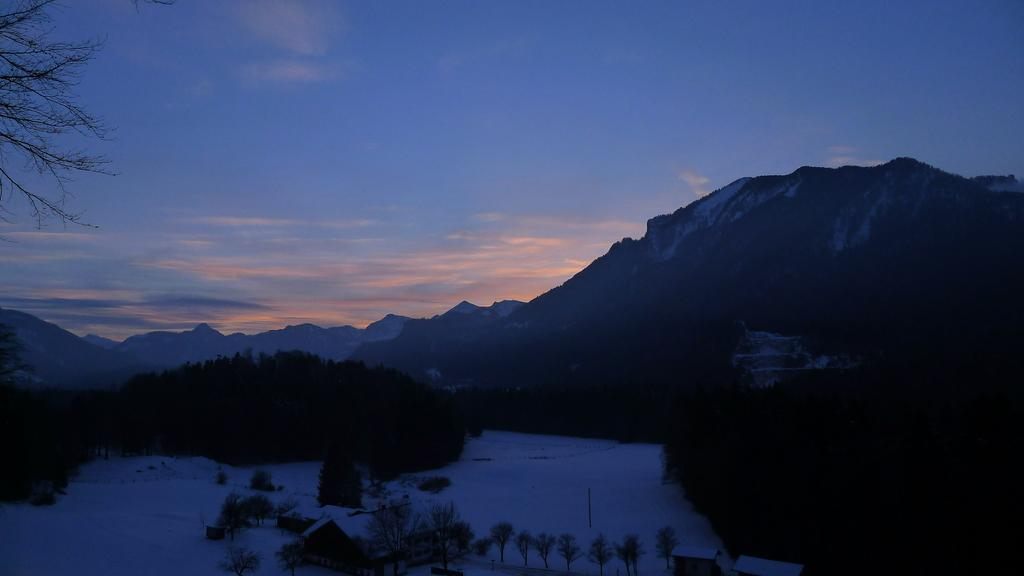What type of structure is located at the bottom of the image? There is a house at the bottom of the image. What type of vegetation can be seen in the image? There are trees in the image. What is the weather like in the image? There is snow visible in the image, indicating a cold or wintery environment. What can be seen in the background of the image? There are mountains, trees, and the sky visible in the background of the image. What type of grain is being harvested in the image? There is no grain visible in the image; it features a house, trees, snow, mountains, and the sky. What color wristband is the person wearing in the image? There are no people or wristbands present in the image. 